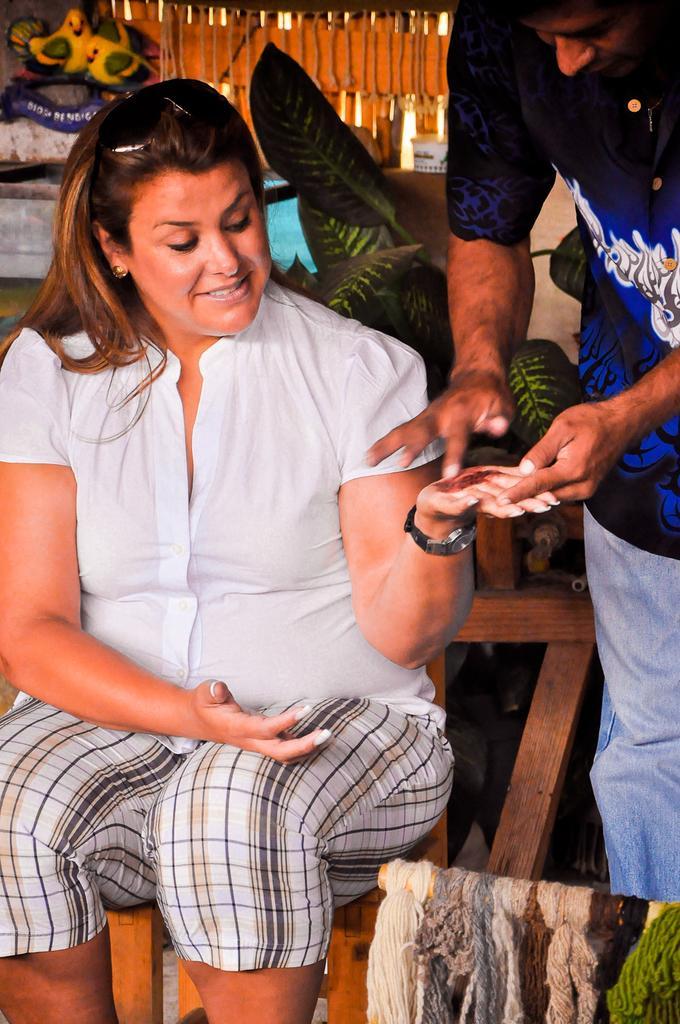Could you give a brief overview of what you see in this image? As we can see in the image there are two people. The woman on the left side is wearing white color dress and sitting on chair. The man on the right side is wearing blue color dress. There is a plant and toy birds. 